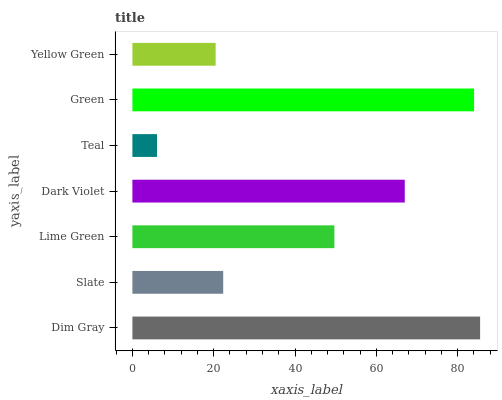Is Teal the minimum?
Answer yes or no. Yes. Is Dim Gray the maximum?
Answer yes or no. Yes. Is Slate the minimum?
Answer yes or no. No. Is Slate the maximum?
Answer yes or no. No. Is Dim Gray greater than Slate?
Answer yes or no. Yes. Is Slate less than Dim Gray?
Answer yes or no. Yes. Is Slate greater than Dim Gray?
Answer yes or no. No. Is Dim Gray less than Slate?
Answer yes or no. No. Is Lime Green the high median?
Answer yes or no. Yes. Is Lime Green the low median?
Answer yes or no. Yes. Is Green the high median?
Answer yes or no. No. Is Slate the low median?
Answer yes or no. No. 